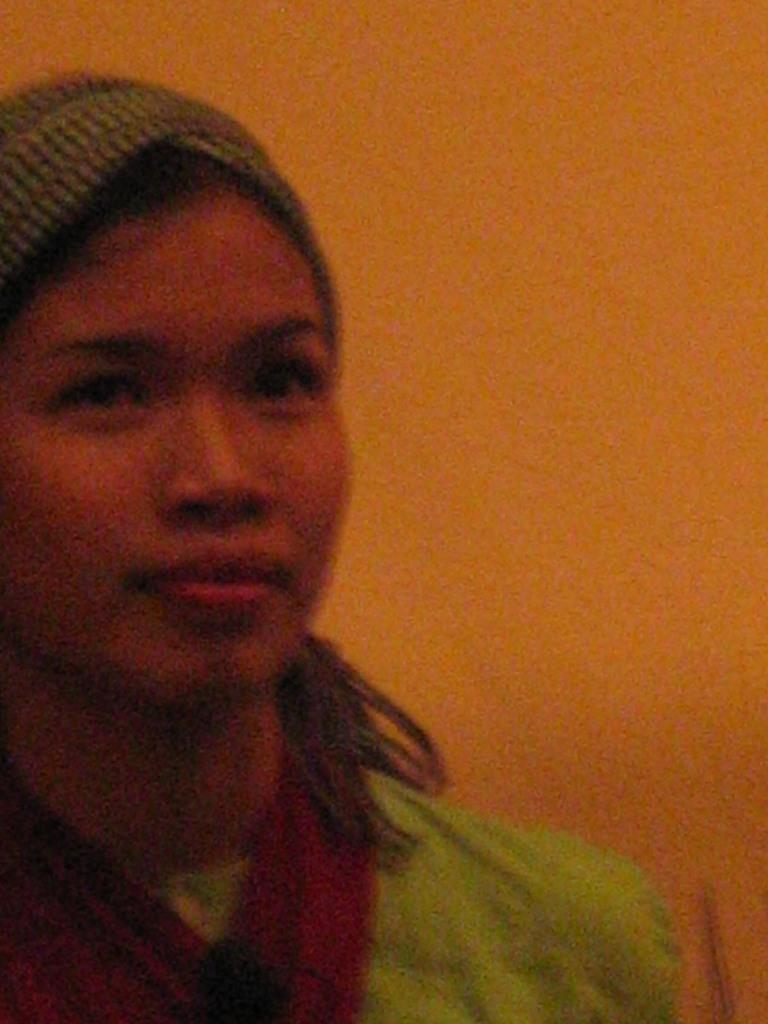Who is the main subject in the picture? There is a woman in the picture. What is the woman wearing? The woman is wearing a dress. What is the woman doing in the picture? The woman is staring. What can be seen in the background of the picture? There is an orange wall in the background of the picture. How would you describe the quality of the image? The picture is blurred. What type of soda is the woman holding in the picture? There is no soda present in the image; the woman is not holding anything. Can you see any pipes in the picture? There are no pipes visible in the image. 